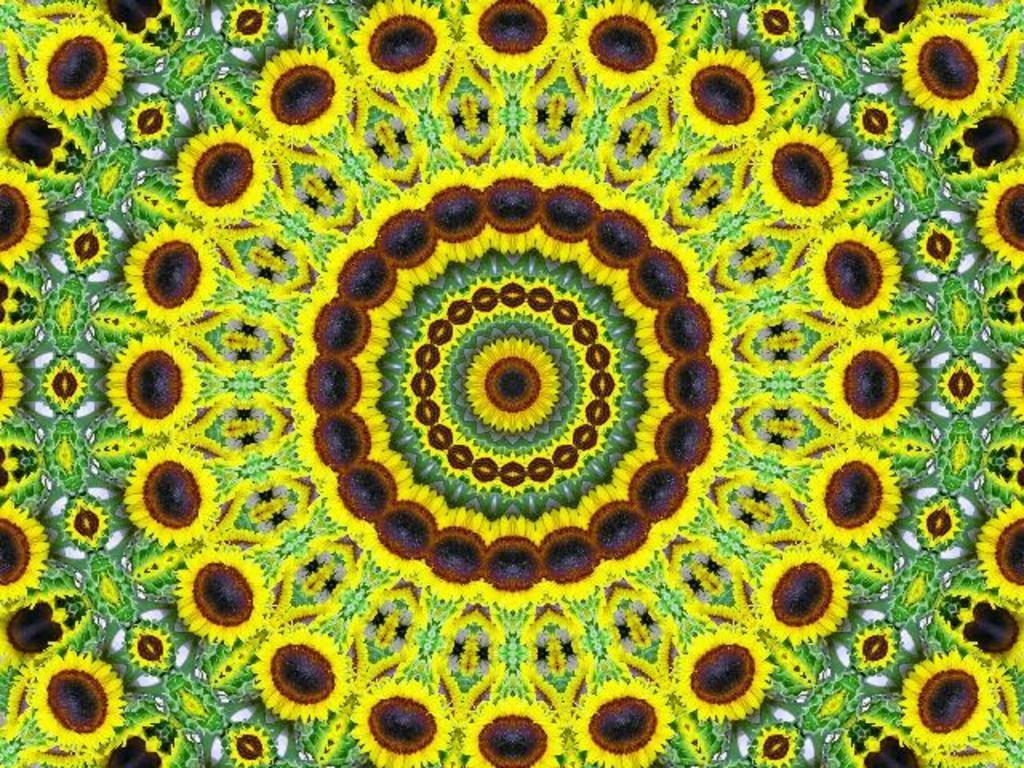Can you describe this image briefly? In this image I can see design which is in yellow, green, brown and black colour. I can also see depiction of sunflowers in this design. 